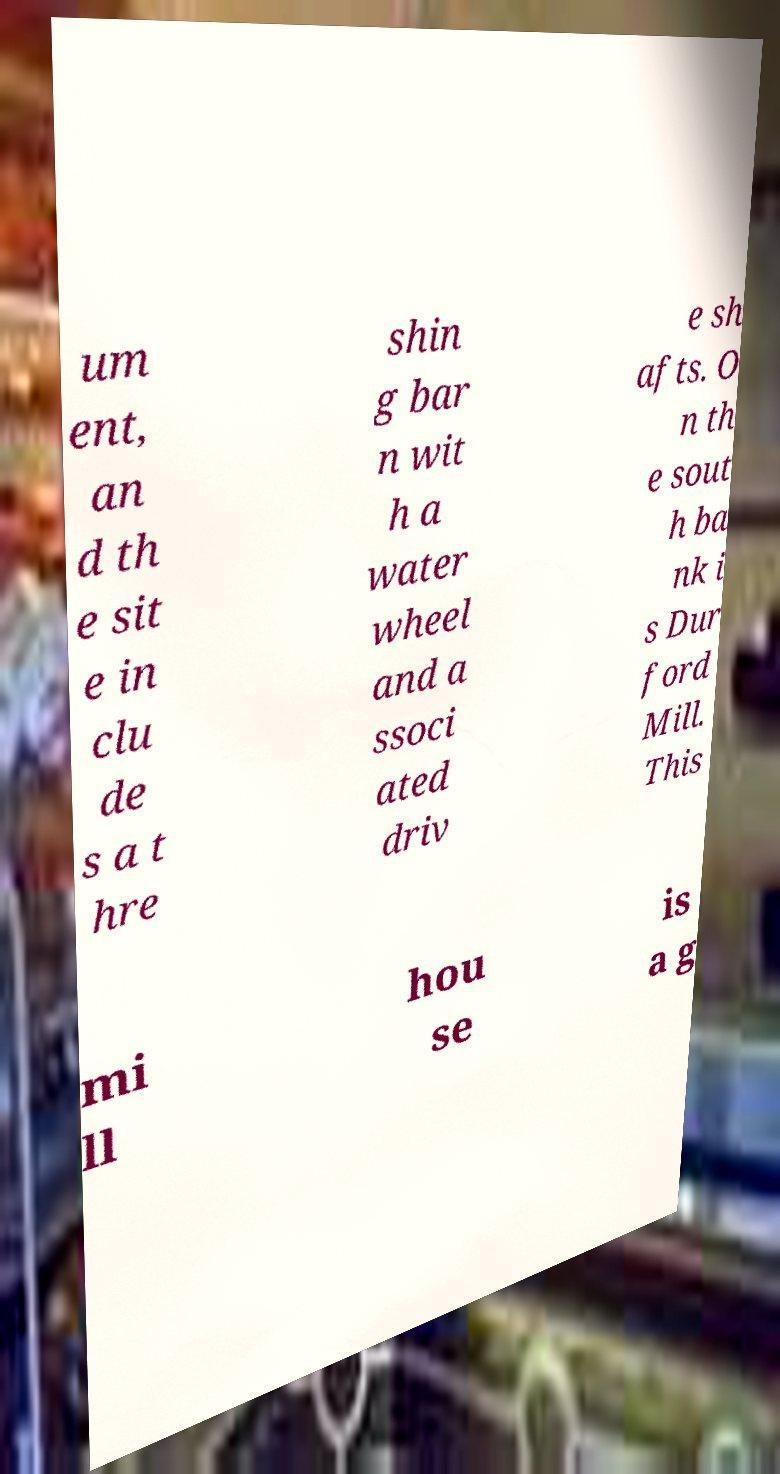Could you extract and type out the text from this image? um ent, an d th e sit e in clu de s a t hre shin g bar n wit h a water wheel and a ssoci ated driv e sh afts. O n th e sout h ba nk i s Dur ford Mill. This mi ll hou se is a g 